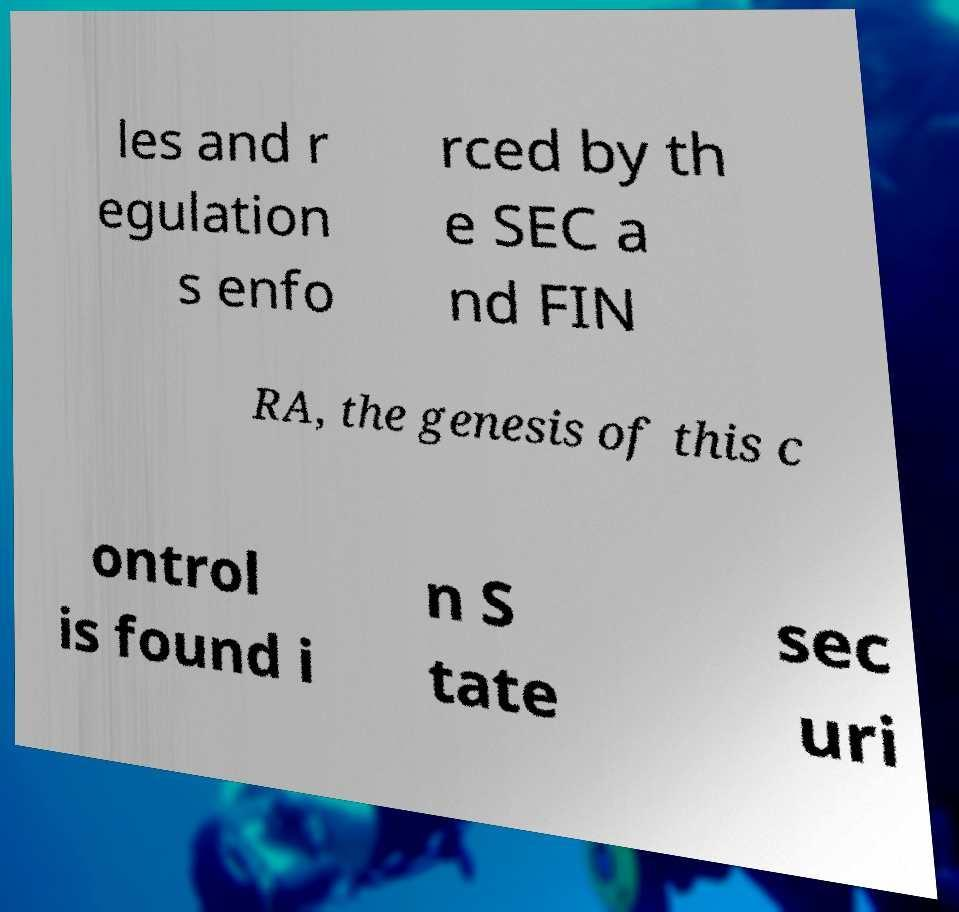Please identify and transcribe the text found in this image. les and r egulation s enfo rced by th e SEC a nd FIN RA, the genesis of this c ontrol is found i n S tate sec uri 